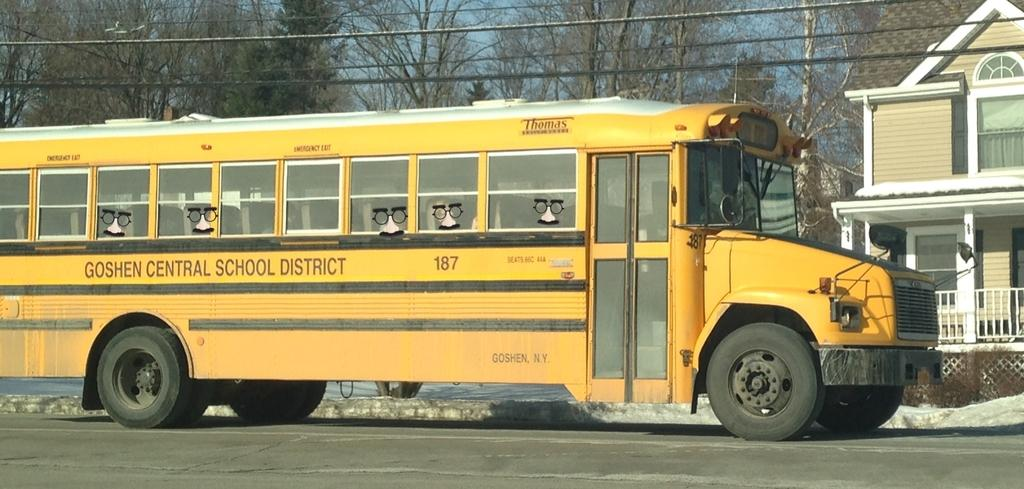What is the main subject of the image? There is a bus in the image. Where is the bus located? The bus is on a road. What can be seen in the background of the image? There are trees and a house in the background of the image. How many cacti are visible in the image? There are no cacti present in the image. What is the stomach size of the bus in the image? The image does not provide information about the bus's stomach size, as buses do not have stomachs. 